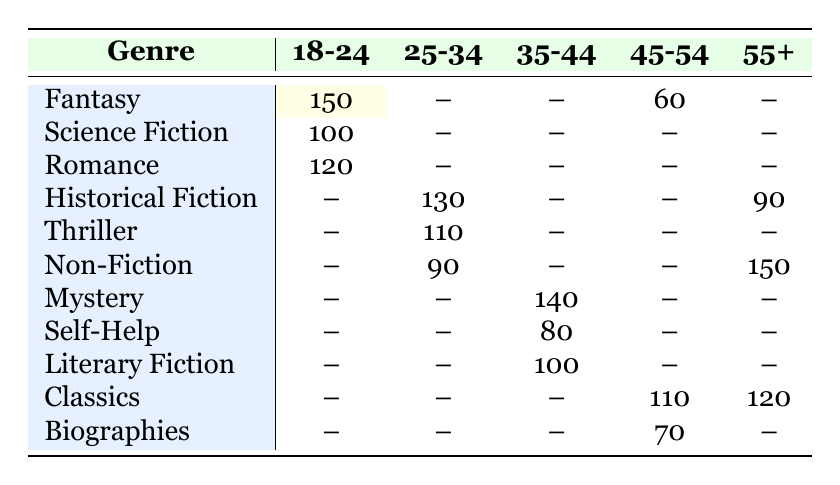What genre has the highest count of readers in the 18-24 age group? The table shows that the highest count in the 18-24 age group is for the Fantasy genre, with a count of 150.
Answer: Fantasy How many readers aged 25-34 prefer Historical Fiction? According to the table, the count for Historical Fiction in the 25-34 age group is 130.
Answer: 130 Is there any genre that has a higher count among readers aged 55+ compared to those aged 45-54? For the 55+ age group, Non-Fiction has a count of 150 and Classics has a count of 120 for the 45-54 age group. Yes, Non-Fiction is higher.
Answer: Yes What is the total count of readers preferring Classics across all age groups? Classics appears in two age groups: 45-54 (count 110) and 55+ (count 120). Adding these gives 110 + 120 = 230.
Answer: 230 Which genre has the lowest count among readers aged 35-44? The one with the lowest count in the 35-44 age group is Self-Help, with a count of 80.
Answer: Self-Help How many readers aged 18-24 prefer either Science Fiction or Romance? Science Fiction has 100, and Romance has 120. The total is 100 + 120 = 220.
Answer: 220 Does the Mystery genre have a higher count than Non-Fiction in any age group? Mystery has a count of 140 in the 35-44 age group, and Non-Fiction has counts of 90 (25-34) and 150 (55+). Therefore, No, it does not.
Answer: No What is the average count of readers for the Fantasy genre across the age groups where it appears? Fantasy is present in the 18-24 (150) and 45-54 (60) age groups. The average is (150 + 60) / 2 = 105.
Answer: 105 How many more readers prefer Thriller than those who prefer Non-Fiction in the age group 25-34? Thriller has a count of 110 and Non-Fiction has a count of 90 in the 25-34 age group. The difference is 110 - 90 = 20.
Answer: 20 